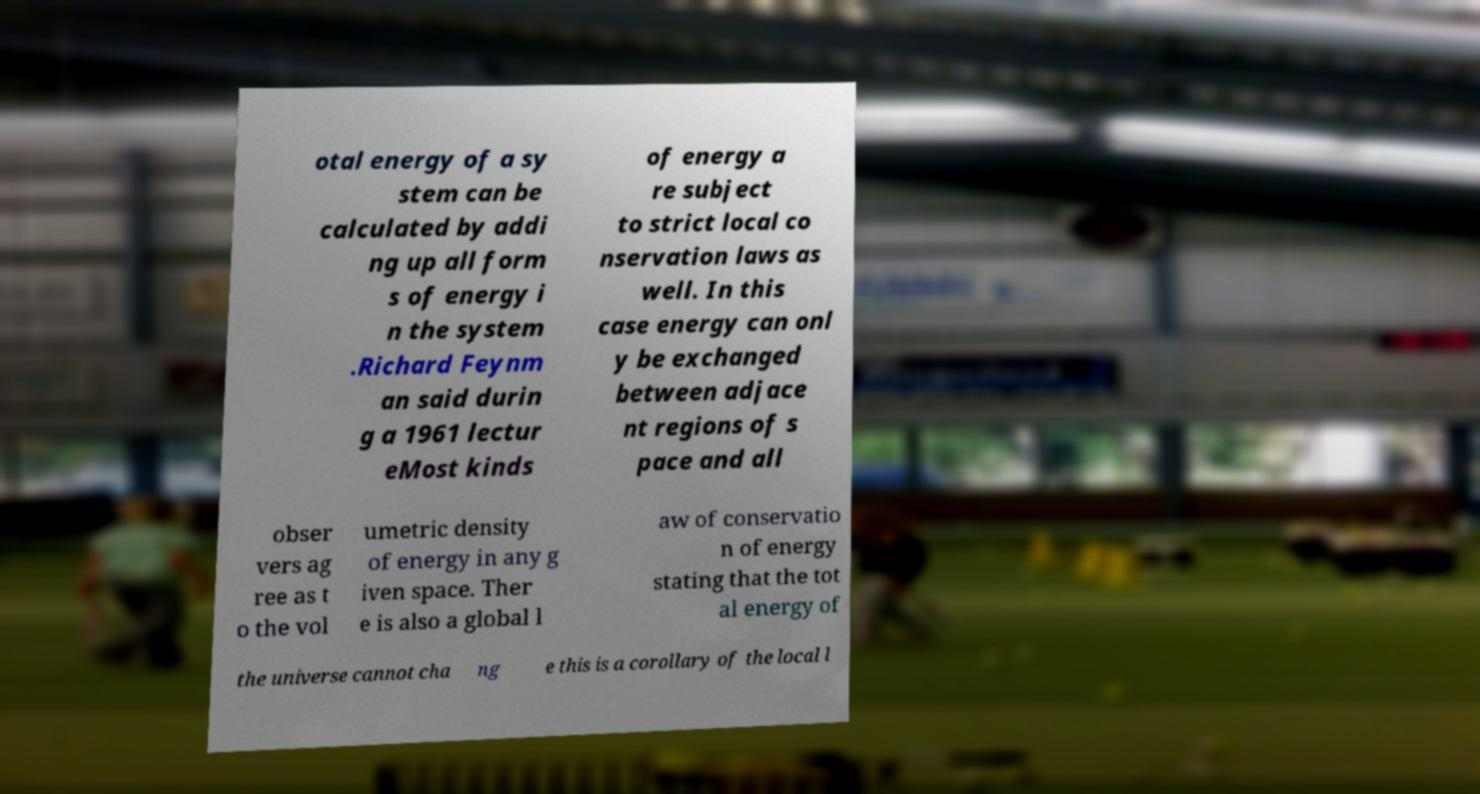I need the written content from this picture converted into text. Can you do that? otal energy of a sy stem can be calculated by addi ng up all form s of energy i n the system .Richard Feynm an said durin g a 1961 lectur eMost kinds of energy a re subject to strict local co nservation laws as well. In this case energy can onl y be exchanged between adjace nt regions of s pace and all obser vers ag ree as t o the vol umetric density of energy in any g iven space. Ther e is also a global l aw of conservatio n of energy stating that the tot al energy of the universe cannot cha ng e this is a corollary of the local l 